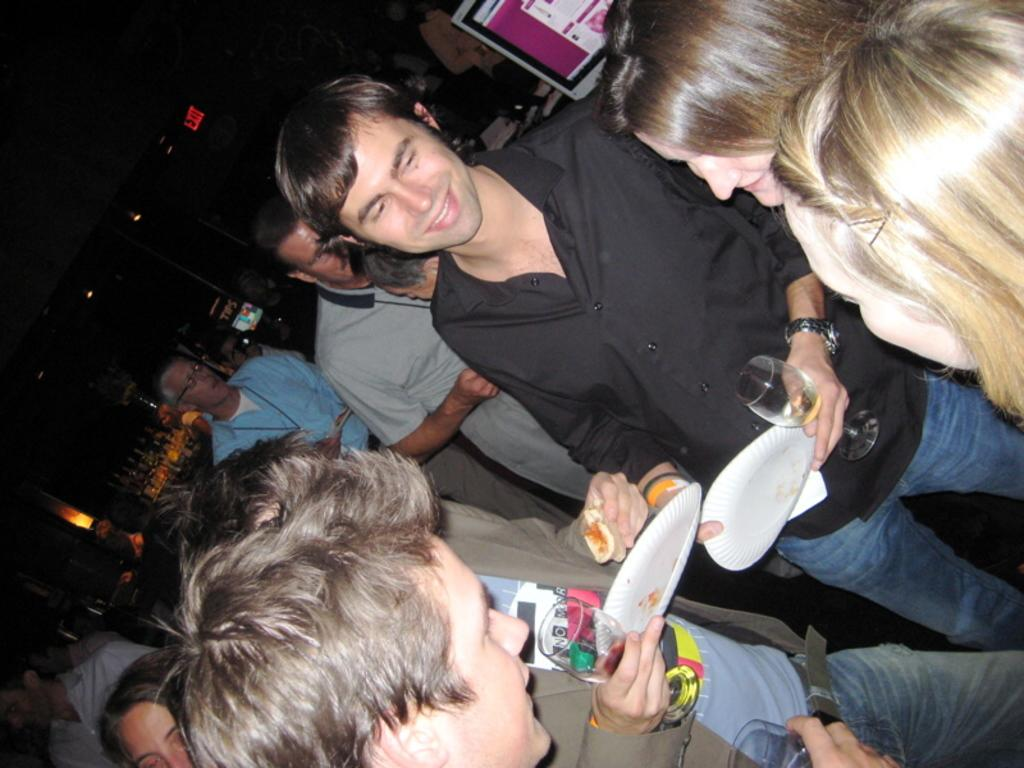What are the people in the image doing? The people in the image are standing and holding paper plates and glasses. What objects are being held by the people in the image? Some of the people are holding paper plates and glasses. What can be seen in the background of the image? The background of the image is dark. What is the system visible in the image? The system in the image is not specified, but it is mentioned that there is a system visible. What type of animal can be seen playing with a curtain in the image? There is no animal or curtain present in the image; it only features people standing and holding paper plates and glasses. 